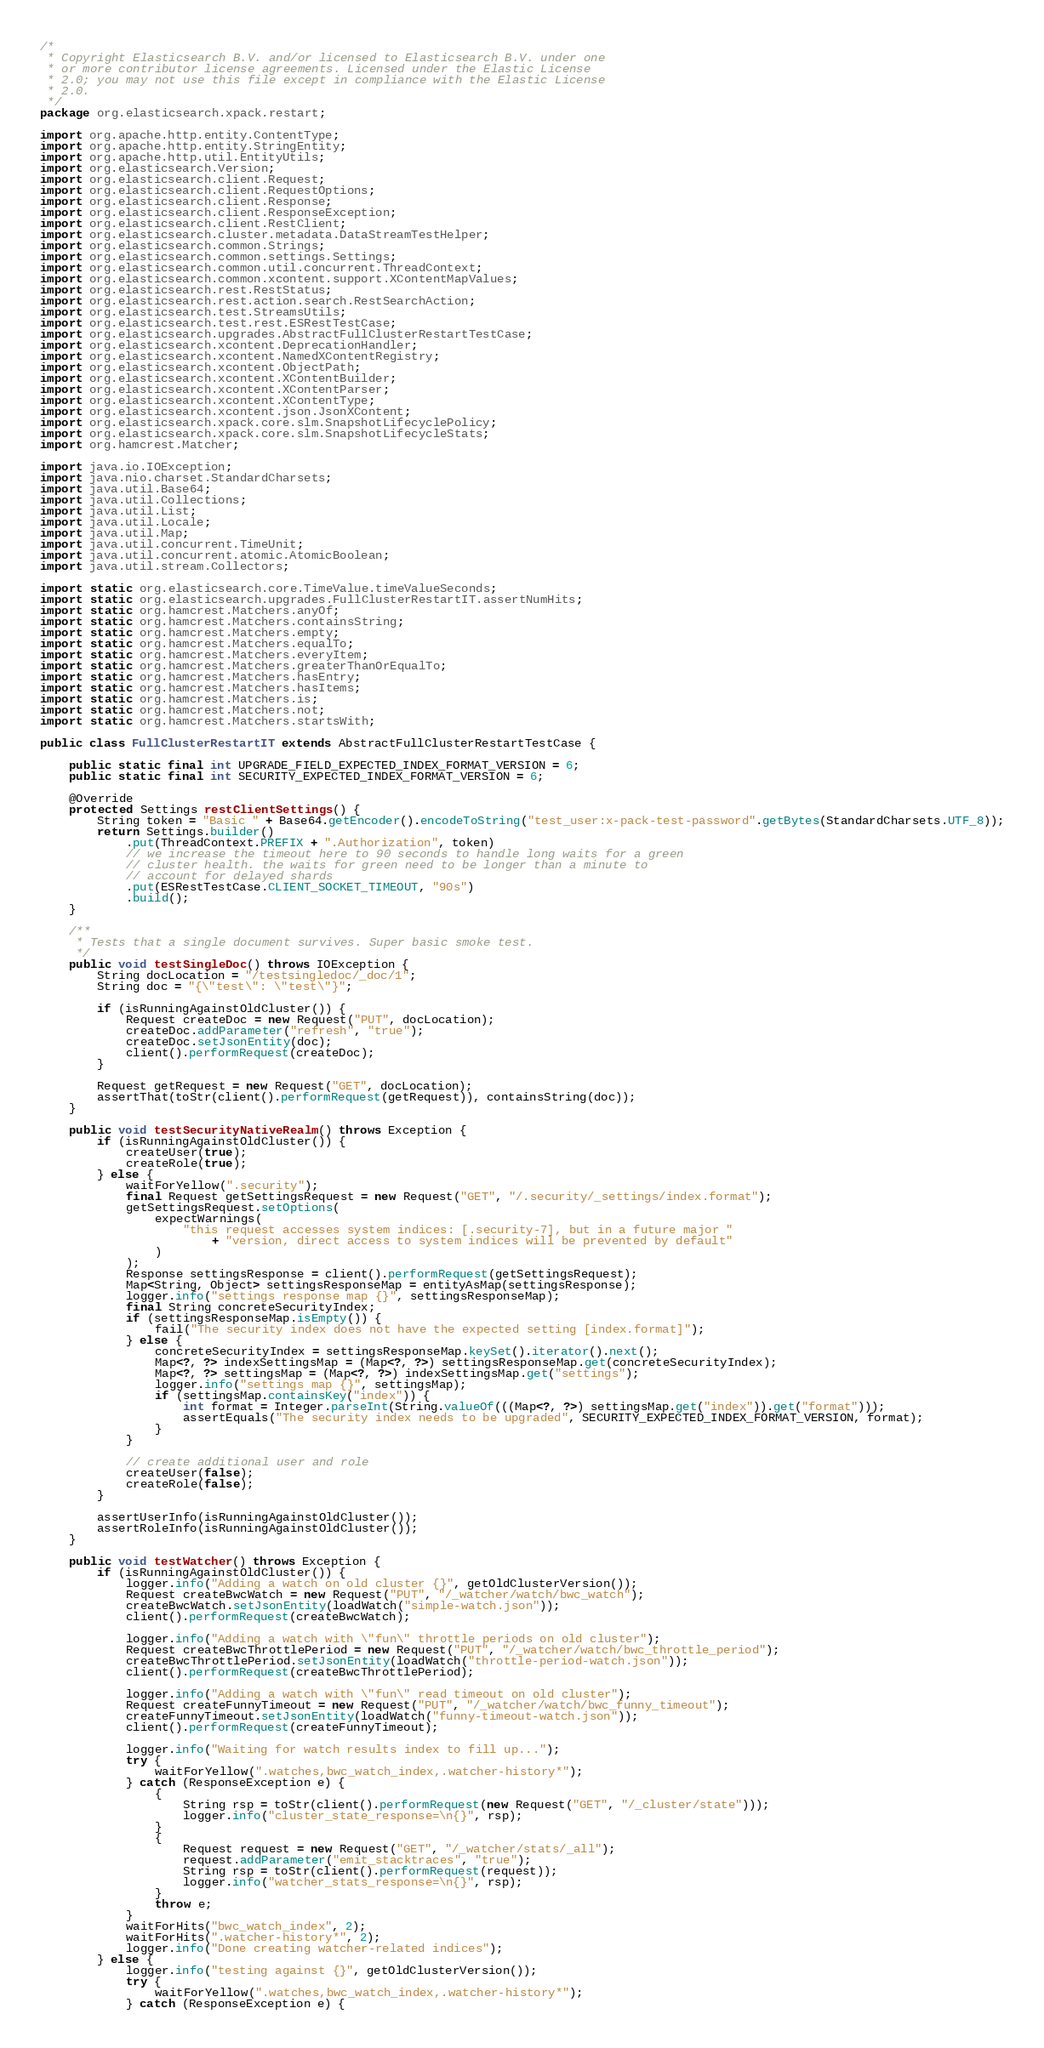Convert code to text. <code><loc_0><loc_0><loc_500><loc_500><_Java_>/*
 * Copyright Elasticsearch B.V. and/or licensed to Elasticsearch B.V. under one
 * or more contributor license agreements. Licensed under the Elastic License
 * 2.0; you may not use this file except in compliance with the Elastic License
 * 2.0.
 */
package org.elasticsearch.xpack.restart;

import org.apache.http.entity.ContentType;
import org.apache.http.entity.StringEntity;
import org.apache.http.util.EntityUtils;
import org.elasticsearch.Version;
import org.elasticsearch.client.Request;
import org.elasticsearch.client.RequestOptions;
import org.elasticsearch.client.Response;
import org.elasticsearch.client.ResponseException;
import org.elasticsearch.client.RestClient;
import org.elasticsearch.cluster.metadata.DataStreamTestHelper;
import org.elasticsearch.common.Strings;
import org.elasticsearch.common.settings.Settings;
import org.elasticsearch.common.util.concurrent.ThreadContext;
import org.elasticsearch.common.xcontent.support.XContentMapValues;
import org.elasticsearch.rest.RestStatus;
import org.elasticsearch.rest.action.search.RestSearchAction;
import org.elasticsearch.test.StreamsUtils;
import org.elasticsearch.test.rest.ESRestTestCase;
import org.elasticsearch.upgrades.AbstractFullClusterRestartTestCase;
import org.elasticsearch.xcontent.DeprecationHandler;
import org.elasticsearch.xcontent.NamedXContentRegistry;
import org.elasticsearch.xcontent.ObjectPath;
import org.elasticsearch.xcontent.XContentBuilder;
import org.elasticsearch.xcontent.XContentParser;
import org.elasticsearch.xcontent.XContentType;
import org.elasticsearch.xcontent.json.JsonXContent;
import org.elasticsearch.xpack.core.slm.SnapshotLifecyclePolicy;
import org.elasticsearch.xpack.core.slm.SnapshotLifecycleStats;
import org.hamcrest.Matcher;

import java.io.IOException;
import java.nio.charset.StandardCharsets;
import java.util.Base64;
import java.util.Collections;
import java.util.List;
import java.util.Locale;
import java.util.Map;
import java.util.concurrent.TimeUnit;
import java.util.concurrent.atomic.AtomicBoolean;
import java.util.stream.Collectors;

import static org.elasticsearch.core.TimeValue.timeValueSeconds;
import static org.elasticsearch.upgrades.FullClusterRestartIT.assertNumHits;
import static org.hamcrest.Matchers.anyOf;
import static org.hamcrest.Matchers.containsString;
import static org.hamcrest.Matchers.empty;
import static org.hamcrest.Matchers.equalTo;
import static org.hamcrest.Matchers.everyItem;
import static org.hamcrest.Matchers.greaterThanOrEqualTo;
import static org.hamcrest.Matchers.hasEntry;
import static org.hamcrest.Matchers.hasItems;
import static org.hamcrest.Matchers.is;
import static org.hamcrest.Matchers.not;
import static org.hamcrest.Matchers.startsWith;

public class FullClusterRestartIT extends AbstractFullClusterRestartTestCase {

    public static final int UPGRADE_FIELD_EXPECTED_INDEX_FORMAT_VERSION = 6;
    public static final int SECURITY_EXPECTED_INDEX_FORMAT_VERSION = 6;

    @Override
    protected Settings restClientSettings() {
        String token = "Basic " + Base64.getEncoder().encodeToString("test_user:x-pack-test-password".getBytes(StandardCharsets.UTF_8));
        return Settings.builder()
            .put(ThreadContext.PREFIX + ".Authorization", token)
            // we increase the timeout here to 90 seconds to handle long waits for a green
            // cluster health. the waits for green need to be longer than a minute to
            // account for delayed shards
            .put(ESRestTestCase.CLIENT_SOCKET_TIMEOUT, "90s")
            .build();
    }

    /**
     * Tests that a single document survives. Super basic smoke test.
     */
    public void testSingleDoc() throws IOException {
        String docLocation = "/testsingledoc/_doc/1";
        String doc = "{\"test\": \"test\"}";

        if (isRunningAgainstOldCluster()) {
            Request createDoc = new Request("PUT", docLocation);
            createDoc.addParameter("refresh", "true");
            createDoc.setJsonEntity(doc);
            client().performRequest(createDoc);
        }

        Request getRequest = new Request("GET", docLocation);
        assertThat(toStr(client().performRequest(getRequest)), containsString(doc));
    }

    public void testSecurityNativeRealm() throws Exception {
        if (isRunningAgainstOldCluster()) {
            createUser(true);
            createRole(true);
        } else {
            waitForYellow(".security");
            final Request getSettingsRequest = new Request("GET", "/.security/_settings/index.format");
            getSettingsRequest.setOptions(
                expectWarnings(
                    "this request accesses system indices: [.security-7], but in a future major "
                        + "version, direct access to system indices will be prevented by default"
                )
            );
            Response settingsResponse = client().performRequest(getSettingsRequest);
            Map<String, Object> settingsResponseMap = entityAsMap(settingsResponse);
            logger.info("settings response map {}", settingsResponseMap);
            final String concreteSecurityIndex;
            if (settingsResponseMap.isEmpty()) {
                fail("The security index does not have the expected setting [index.format]");
            } else {
                concreteSecurityIndex = settingsResponseMap.keySet().iterator().next();
                Map<?, ?> indexSettingsMap = (Map<?, ?>) settingsResponseMap.get(concreteSecurityIndex);
                Map<?, ?> settingsMap = (Map<?, ?>) indexSettingsMap.get("settings");
                logger.info("settings map {}", settingsMap);
                if (settingsMap.containsKey("index")) {
                    int format = Integer.parseInt(String.valueOf(((Map<?, ?>) settingsMap.get("index")).get("format")));
                    assertEquals("The security index needs to be upgraded", SECURITY_EXPECTED_INDEX_FORMAT_VERSION, format);
                }
            }

            // create additional user and role
            createUser(false);
            createRole(false);
        }

        assertUserInfo(isRunningAgainstOldCluster());
        assertRoleInfo(isRunningAgainstOldCluster());
    }

    public void testWatcher() throws Exception {
        if (isRunningAgainstOldCluster()) {
            logger.info("Adding a watch on old cluster {}", getOldClusterVersion());
            Request createBwcWatch = new Request("PUT", "/_watcher/watch/bwc_watch");
            createBwcWatch.setJsonEntity(loadWatch("simple-watch.json"));
            client().performRequest(createBwcWatch);

            logger.info("Adding a watch with \"fun\" throttle periods on old cluster");
            Request createBwcThrottlePeriod = new Request("PUT", "/_watcher/watch/bwc_throttle_period");
            createBwcThrottlePeriod.setJsonEntity(loadWatch("throttle-period-watch.json"));
            client().performRequest(createBwcThrottlePeriod);

            logger.info("Adding a watch with \"fun\" read timeout on old cluster");
            Request createFunnyTimeout = new Request("PUT", "/_watcher/watch/bwc_funny_timeout");
            createFunnyTimeout.setJsonEntity(loadWatch("funny-timeout-watch.json"));
            client().performRequest(createFunnyTimeout);

            logger.info("Waiting for watch results index to fill up...");
            try {
                waitForYellow(".watches,bwc_watch_index,.watcher-history*");
            } catch (ResponseException e) {
                {
                    String rsp = toStr(client().performRequest(new Request("GET", "/_cluster/state")));
                    logger.info("cluster_state_response=\n{}", rsp);
                }
                {
                    Request request = new Request("GET", "/_watcher/stats/_all");
                    request.addParameter("emit_stacktraces", "true");
                    String rsp = toStr(client().performRequest(request));
                    logger.info("watcher_stats_response=\n{}", rsp);
                }
                throw e;
            }
            waitForHits("bwc_watch_index", 2);
            waitForHits(".watcher-history*", 2);
            logger.info("Done creating watcher-related indices");
        } else {
            logger.info("testing against {}", getOldClusterVersion());
            try {
                waitForYellow(".watches,bwc_watch_index,.watcher-history*");
            } catch (ResponseException e) {</code> 